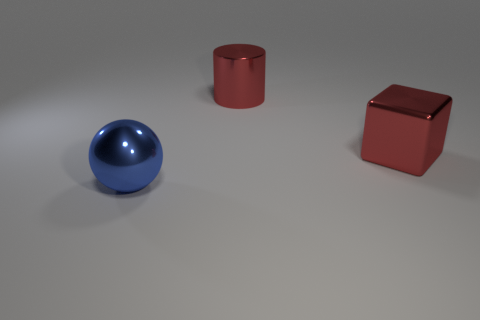Add 1 big red cylinders. How many objects exist? 4 Subtract all balls. How many objects are left? 2 Subtract 1 cubes. How many cubes are left? 0 Subtract all brown shiny cylinders. Subtract all large shiny cubes. How many objects are left? 2 Add 3 blue balls. How many blue balls are left? 4 Add 2 tiny purple matte cylinders. How many tiny purple matte cylinders exist? 2 Subtract 0 green spheres. How many objects are left? 3 Subtract all green spheres. Subtract all brown cylinders. How many spheres are left? 1 